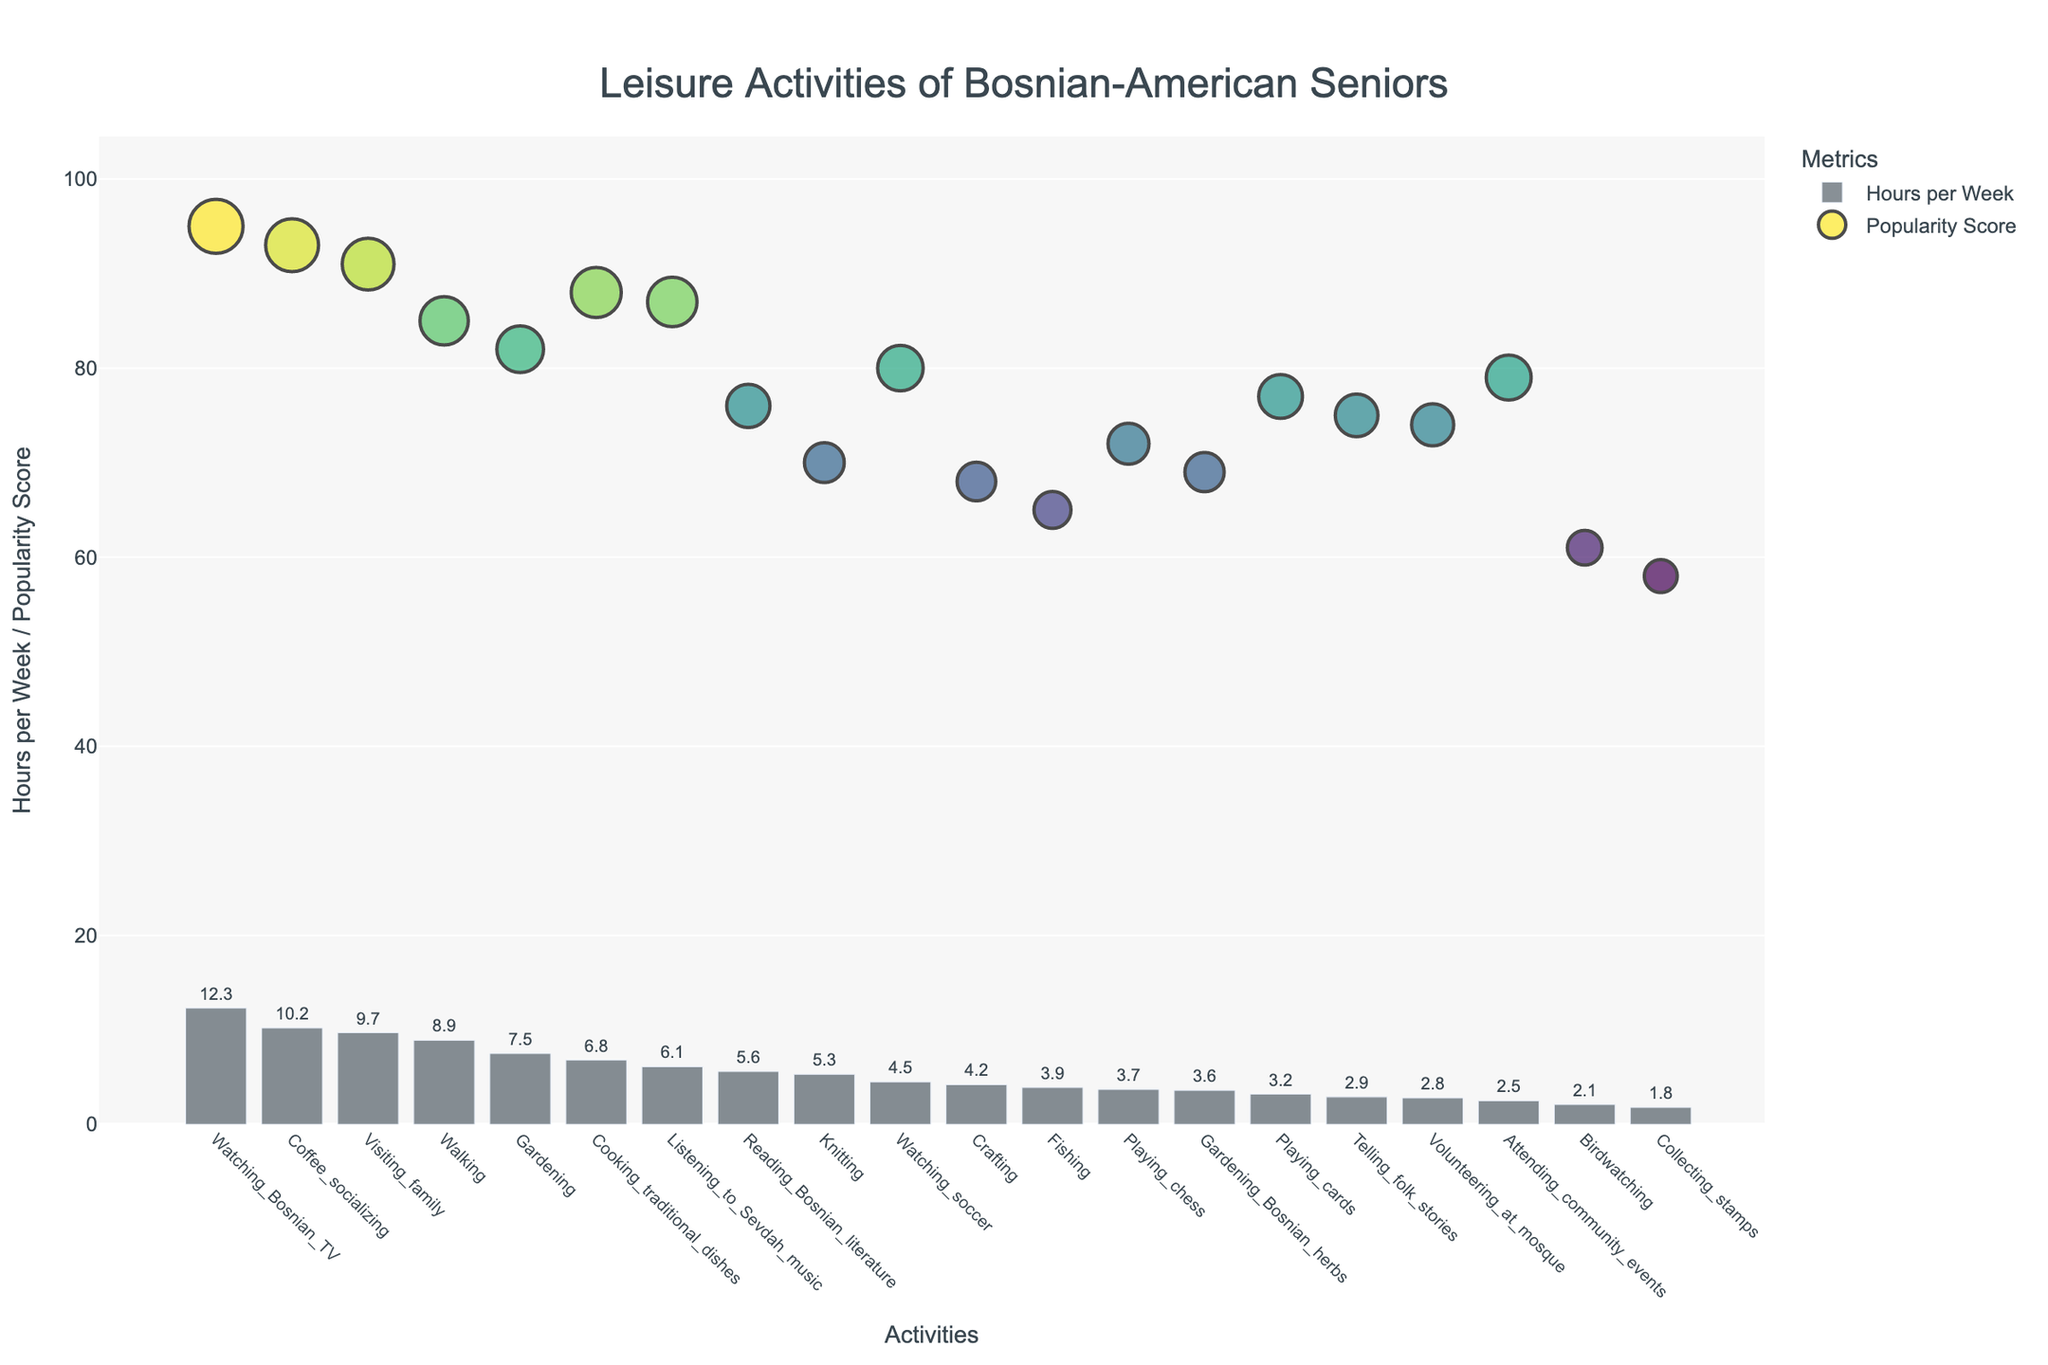Which activity has the highest hourly engagement per week? The activity with the highest bar in the bar chart represents the highest hours per week.
Answer: Watching Bosnian TV What is the popularity score of "Gardening"? Locate "Gardening" on the x-axis, then check the y-coordinate of the dot representing its popularity score.
Answer: 82 Which activities have both high engagement (more than 8 hours per week) and high popularity (above 90)? Identify activities where the bar height is over 8 hours and the popularity marker is above 90 on the y-axis.
Answer: Watching Bosnian TV, Coffee socializing, Visiting family What is the total weekly engagement for "Gardening" and "Gardening Bosnian herbs"? Sum the hours per week for both activities from the bars.
Answer: 11.1 hours How does "Volunteering at mosque" compare to "Attending community events" in terms of popularity? Compare the positions of their popularity markers on the y-axis.
Answer: Attending community events is more popular What is the range of hours per week for the activities shown? Identify the minimum and maximum bar heights to find the range.
Answer: 1.8 to 12.3 hours Which activity is more popular, "Playing chess" or "Playing cards"? Compare the popularity scores marked by the dots for both activities.
Answer: Playing cards Are there any activities with equal hours per week? Look for bars of identical height to identify such activities.
Answer: Gardening Bosnian herbs and Playing chess What is the average popularity score of the top three activities by hours per week? Identify the top three activities, sum their popularity scores, and divide by three.
Answer: (95 + 93 + 91) / 3 = 93 